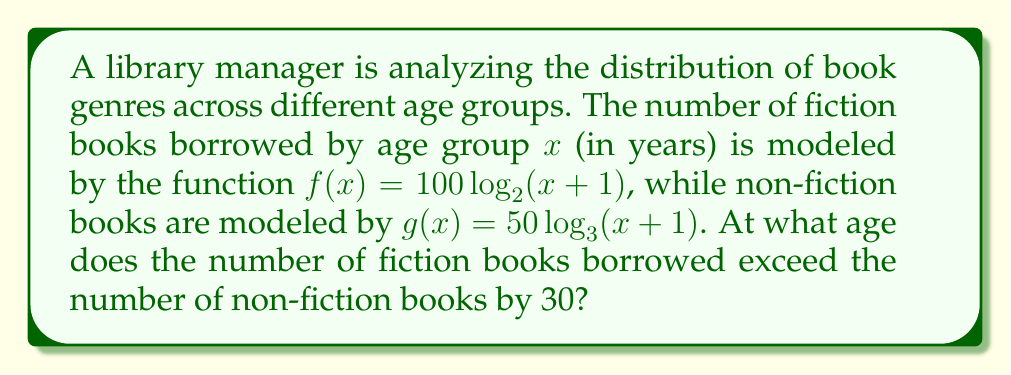Solve this math problem. To solve this problem, we need to follow these steps:

1) We're looking for the age x where the difference between fiction and non-fiction books is 30. We can express this as an equation:

   $f(x) - g(x) = 30$

2) Substitute the given functions:

   $100 \log_2(x+1) - 50 \log_3(x+1) = 30$

3) To solve this, we need to use the change of base formula to convert both logarithms to natural logarithms:

   $100 \frac{\ln(x+1)}{\ln(2)} - 50 \frac{\ln(x+1)}{\ln(3)} = 30$

4) Factor out $\ln(x+1)$:

   $\ln(x+1) (\frac{100}{\ln(2)} - \frac{50}{\ln(3)}) = 30$

5) Solve for $\ln(x+1)$:

   $\ln(x+1) = \frac{30}{\frac{100}{\ln(2)} - \frac{50}{\ln(3)}}$

6) Now we can solve for x:

   $x+1 = e^{\frac{30}{\frac{100}{\ln(2)} - \frac{50}{\ln(3)}}}$

   $x = e^{\frac{30}{\frac{100}{\ln(2)} - \frac{50}{\ln(3)}}} - 1$

7) Calculate this value (you may need a calculator):

   $x \approx 15.95$

8) Since age must be a whole number, we round up to the next integer.
Answer: 16 years 